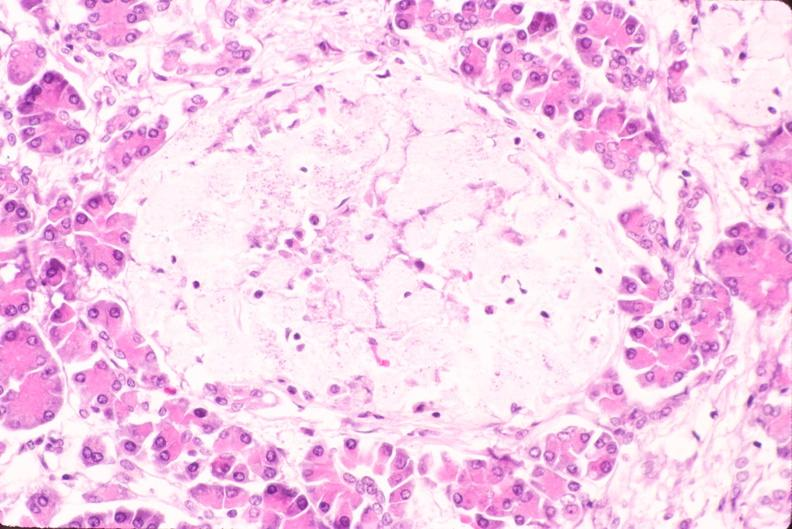what is present?
Answer the question using a single word or phrase. Endocrine 